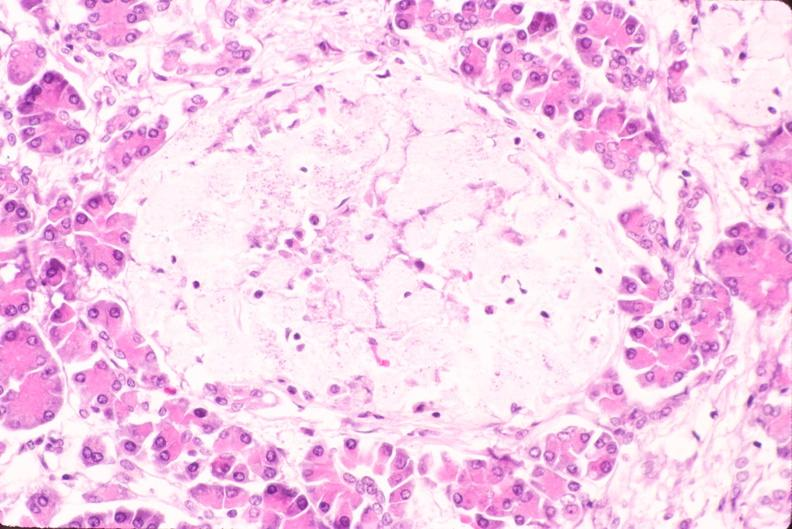what is present?
Answer the question using a single word or phrase. Endocrine 